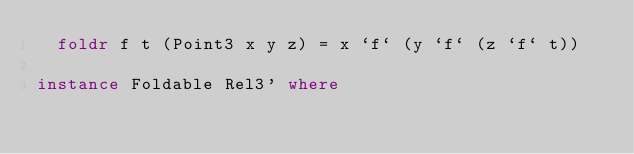Convert code to text. <code><loc_0><loc_0><loc_500><loc_500><_Haskell_>  foldr f t (Point3 x y z) = x `f` (y `f` (z `f` t))

instance Foldable Rel3' where</code> 